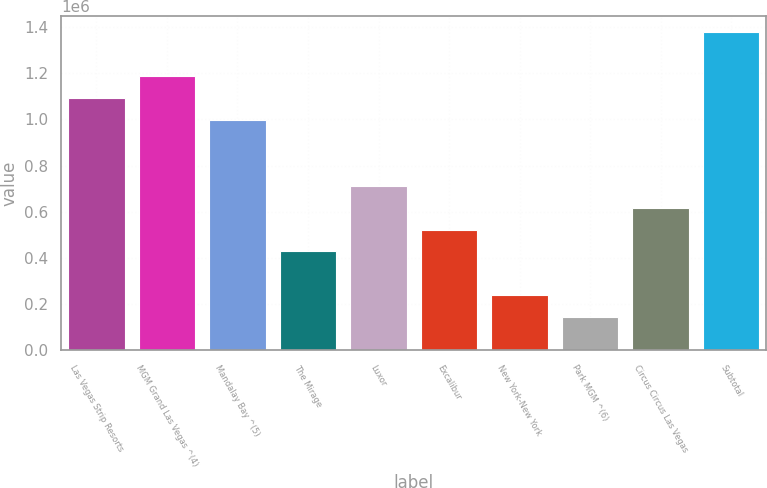<chart> <loc_0><loc_0><loc_500><loc_500><bar_chart><fcel>Las Vegas Strip Resorts<fcel>MGM Grand Las Vegas ^(4)<fcel>Mandalay Bay ^(5)<fcel>The Mirage<fcel>Luxor<fcel>Excalibur<fcel>New York-New York<fcel>Park MGM ^(6)<fcel>Circus Circus Las Vegas<fcel>Subtotal<nl><fcel>1.093e+06<fcel>1.188e+06<fcel>998000<fcel>428000<fcel>713000<fcel>523000<fcel>238000<fcel>143000<fcel>618000<fcel>1.378e+06<nl></chart> 